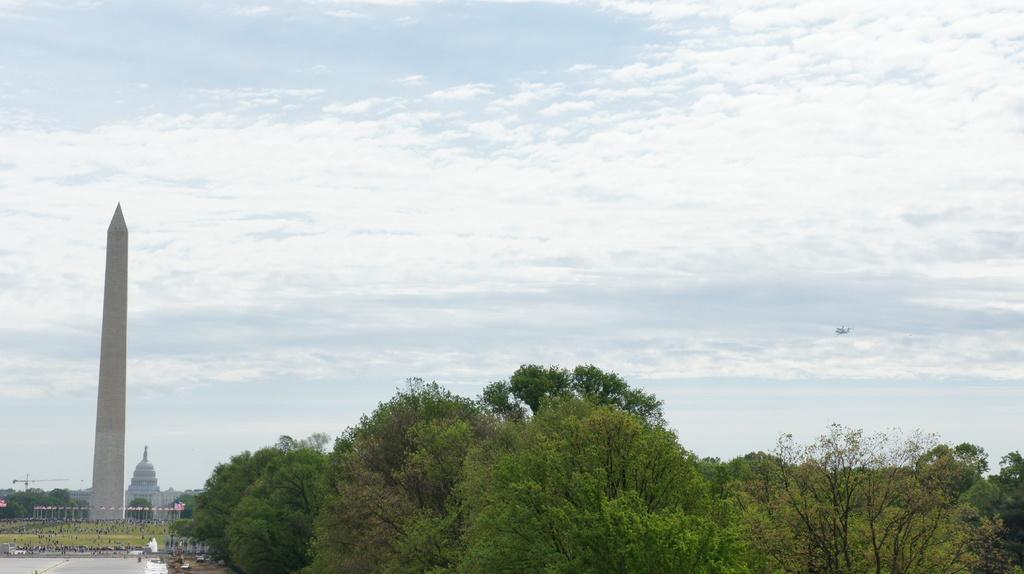Can you describe this image briefly? In this image I can see number of trees, few buildings, clouds and the sky. I can also see green ground over there. 